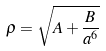<formula> <loc_0><loc_0><loc_500><loc_500>\rho = \sqrt { A + \frac { B } { a ^ { 6 } } }</formula> 